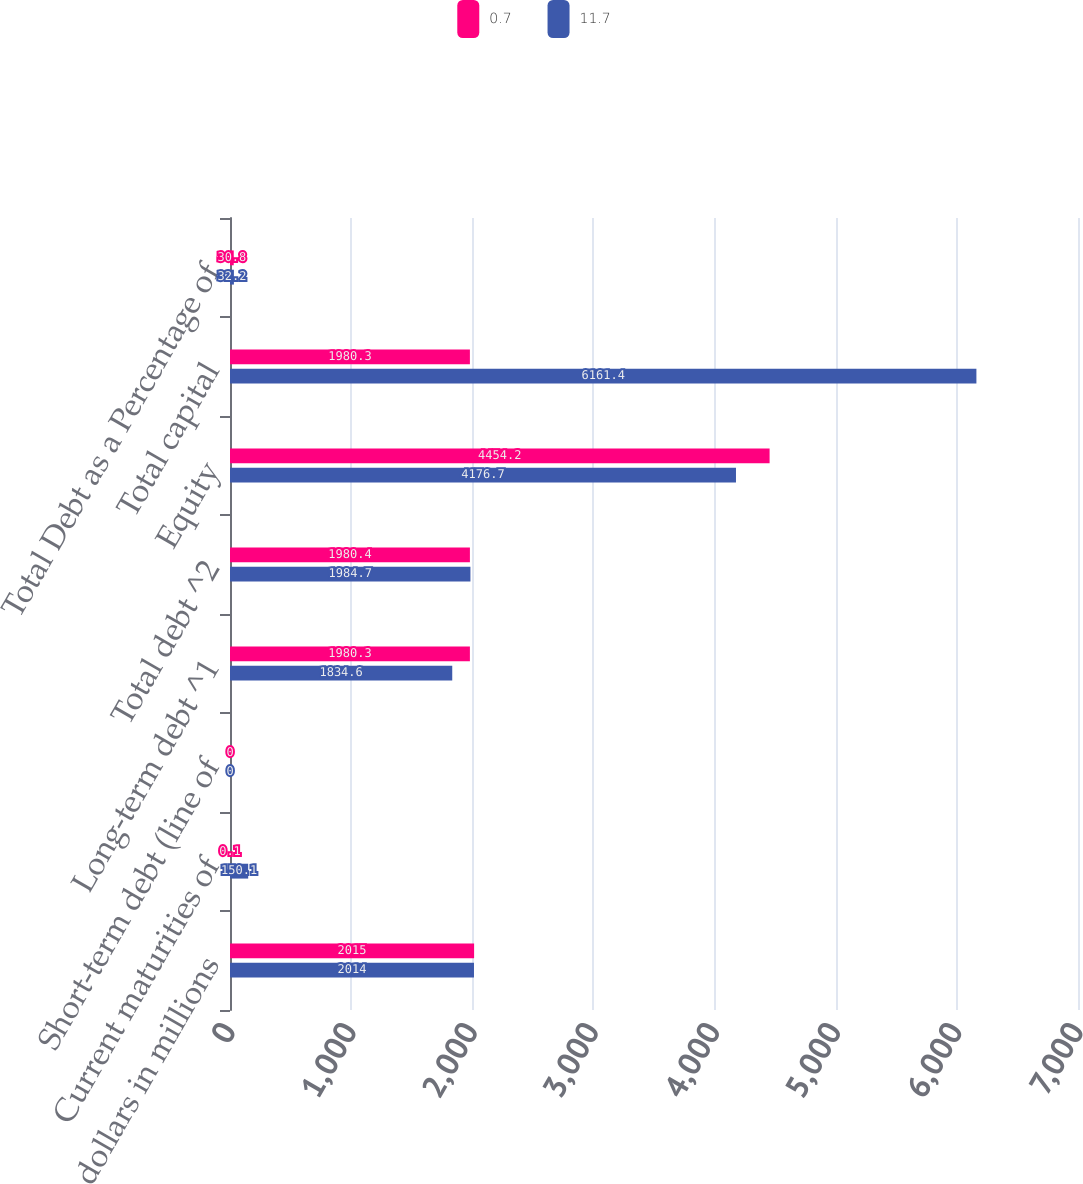Convert chart to OTSL. <chart><loc_0><loc_0><loc_500><loc_500><stacked_bar_chart><ecel><fcel>dollars in millions<fcel>Current maturities of<fcel>Short-term debt (line of<fcel>Long-term debt ^1<fcel>Total debt ^2<fcel>Equity<fcel>Total capital<fcel>Total Debt as a Percentage of<nl><fcel>0.7<fcel>2015<fcel>0.1<fcel>0<fcel>1980.3<fcel>1980.4<fcel>4454.2<fcel>1980.3<fcel>30.8<nl><fcel>11.7<fcel>2014<fcel>150.1<fcel>0<fcel>1834.6<fcel>1984.7<fcel>4176.7<fcel>6161.4<fcel>32.2<nl></chart> 